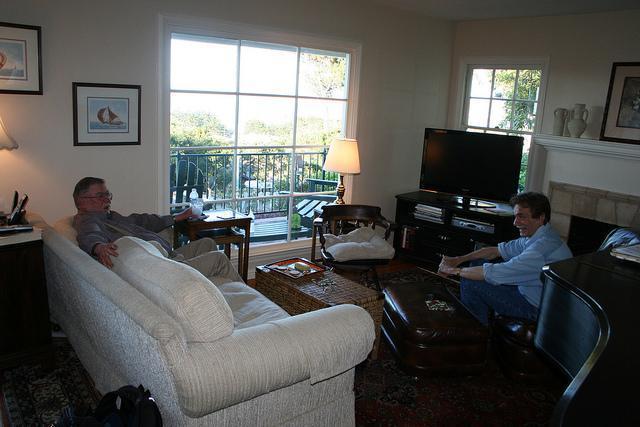How many pictures are on the wall?
Give a very brief answer. 3. How many people are visible in this picture?
Give a very brief answer. 2. How many pillows are in the picture?
Give a very brief answer. 1. How many people are there?
Give a very brief answer. 2. How many couches are visible?
Give a very brief answer. 2. How many chairs are in the photo?
Give a very brief answer. 2. 